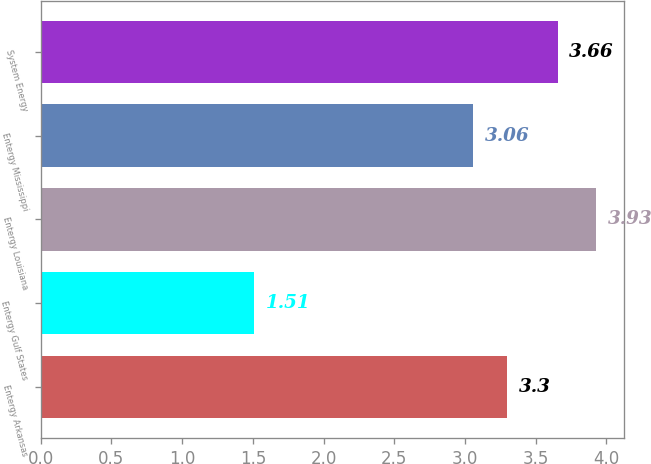<chart> <loc_0><loc_0><loc_500><loc_500><bar_chart><fcel>Entergy Arkansas<fcel>Entergy Gulf States<fcel>Entergy Louisiana<fcel>Entergy Mississippi<fcel>System Energy<nl><fcel>3.3<fcel>1.51<fcel>3.93<fcel>3.06<fcel>3.66<nl></chart> 